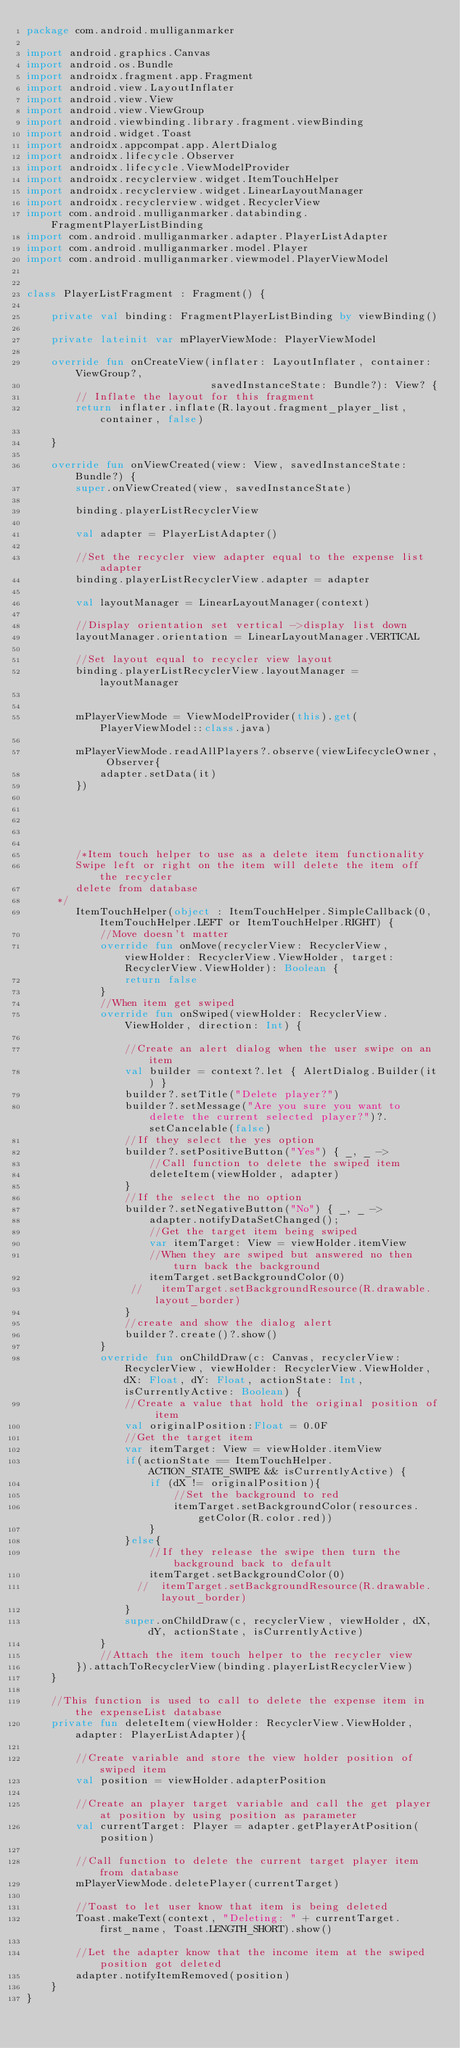<code> <loc_0><loc_0><loc_500><loc_500><_Kotlin_>package com.android.mulliganmarker

import android.graphics.Canvas
import android.os.Bundle
import androidx.fragment.app.Fragment
import android.view.LayoutInflater
import android.view.View
import android.view.ViewGroup
import android.viewbinding.library.fragment.viewBinding
import android.widget.Toast
import androidx.appcompat.app.AlertDialog
import androidx.lifecycle.Observer
import androidx.lifecycle.ViewModelProvider
import androidx.recyclerview.widget.ItemTouchHelper
import androidx.recyclerview.widget.LinearLayoutManager
import androidx.recyclerview.widget.RecyclerView
import com.android.mulliganmarker.databinding.FragmentPlayerListBinding
import com.android.mulliganmarker.adapter.PlayerListAdapter
import com.android.mulliganmarker.model.Player
import com.android.mulliganmarker.viewmodel.PlayerViewModel


class PlayerListFragment : Fragment() {

    private val binding: FragmentPlayerListBinding by viewBinding()

    private lateinit var mPlayerViewMode: PlayerViewModel

    override fun onCreateView(inflater: LayoutInflater, container: ViewGroup?,
                              savedInstanceState: Bundle?): View? {
        // Inflate the layout for this fragment
        return inflater.inflate(R.layout.fragment_player_list, container, false)

    }

    override fun onViewCreated(view: View, savedInstanceState: Bundle?) {
        super.onViewCreated(view, savedInstanceState)

        binding.playerListRecyclerView

        val adapter = PlayerListAdapter()

        //Set the recycler view adapter equal to the expense list adapter
        binding.playerListRecyclerView.adapter = adapter

        val layoutManager = LinearLayoutManager(context)

        //Display orientation set vertical ->display list down
        layoutManager.orientation = LinearLayoutManager.VERTICAL

        //Set layout equal to recycler view layout
        binding.playerListRecyclerView.layoutManager =  layoutManager


        mPlayerViewMode = ViewModelProvider(this).get(PlayerViewModel::class.java)

        mPlayerViewMode.readAllPlayers?.observe(viewLifecycleOwner, Observer{
            adapter.setData(it)
        })





        /*Item touch helper to use as a delete item functionality
        Swipe left or right on the item will delete the item off the recycler
        delete from database
     */
        ItemTouchHelper(object : ItemTouchHelper.SimpleCallback(0, ItemTouchHelper.LEFT or ItemTouchHelper.RIGHT) {
            //Move doesn't matter
            override fun onMove(recyclerView: RecyclerView, viewHolder: RecyclerView.ViewHolder, target: RecyclerView.ViewHolder): Boolean {
                return false
            }
            //When item get swiped
            override fun onSwiped(viewHolder: RecyclerView.ViewHolder, direction: Int) {

                //Create an alert dialog when the user swipe on an item
                val builder = context?.let { AlertDialog.Builder(it) }
                builder?.setTitle("Delete player?")
                builder?.setMessage("Are you sure you want to delete the current selected player?")?.setCancelable(false)
                //If they select the yes option
                builder?.setPositiveButton("Yes") { _, _ ->
                    //Call function to delete the swiped item
                    deleteItem(viewHolder, adapter)
                }
                //If the select the no option
                builder?.setNegativeButton("No") { _, _ ->
                    adapter.notifyDataSetChanged();
                    //Get the target item being swiped
                    var itemTarget: View = viewHolder.itemView
                    //When they are swiped but answered no then turn back the background
                    itemTarget.setBackgroundColor(0)
                 //   itemTarget.setBackgroundResource(R.drawable.layout_border)
                }
                //create and show the dialog alert
                builder?.create()?.show()
            }
            override fun onChildDraw(c: Canvas, recyclerView: RecyclerView, viewHolder: RecyclerView.ViewHolder, dX: Float, dY: Float, actionState: Int, isCurrentlyActive: Boolean) {
                //Create a value that hold the original position of item
                val originalPosition:Float = 0.0F
                //Get the target item
                var itemTarget: View = viewHolder.itemView
                if(actionState == ItemTouchHelper.ACTION_STATE_SWIPE && isCurrentlyActive) {
                    if (dX != originalPosition){
                        //Set the background to red
                        itemTarget.setBackgroundColor(resources.getColor(R.color.red))
                    }
                }else{
                    //If they release the swipe then turn the background back to default
                    itemTarget.setBackgroundColor(0)
                  //  itemTarget.setBackgroundResource(R.drawable.layout_border)
                }
                super.onChildDraw(c, recyclerView, viewHolder, dX, dY, actionState, isCurrentlyActive)
            }
            //Attach the item touch helper to the recycler view
        }).attachToRecyclerView(binding.playerListRecyclerView)
    }

    //This function is used to call to delete the expense item in the expenseList database
    private fun deleteItem(viewHolder: RecyclerView.ViewHolder, adapter: PlayerListAdapter){

        //Create variable and store the view holder position of swiped item
        val position = viewHolder.adapterPosition

        //Create an player target variable and call the get player at position by using position as parameter
        val currentTarget: Player = adapter.getPlayerAtPosition(position)

        //Call function to delete the current target player item from database
        mPlayerViewMode.deletePlayer(currentTarget)

        //Toast to let user know that item is being deleted
        Toast.makeText(context, "Deleting: " + currentTarget.first_name, Toast.LENGTH_SHORT).show()

        //Let the adapter know that the income item at the swiped position got deleted
        adapter.notifyItemRemoved(position)
    }
}</code> 